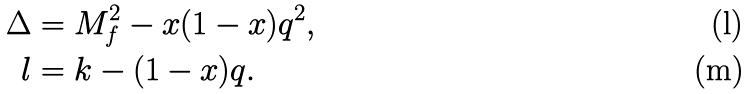<formula> <loc_0><loc_0><loc_500><loc_500>\Delta & = M _ { f } ^ { 2 } - x ( 1 - x ) q ^ { 2 } , \\ l & = k - ( 1 - x ) q .</formula> 